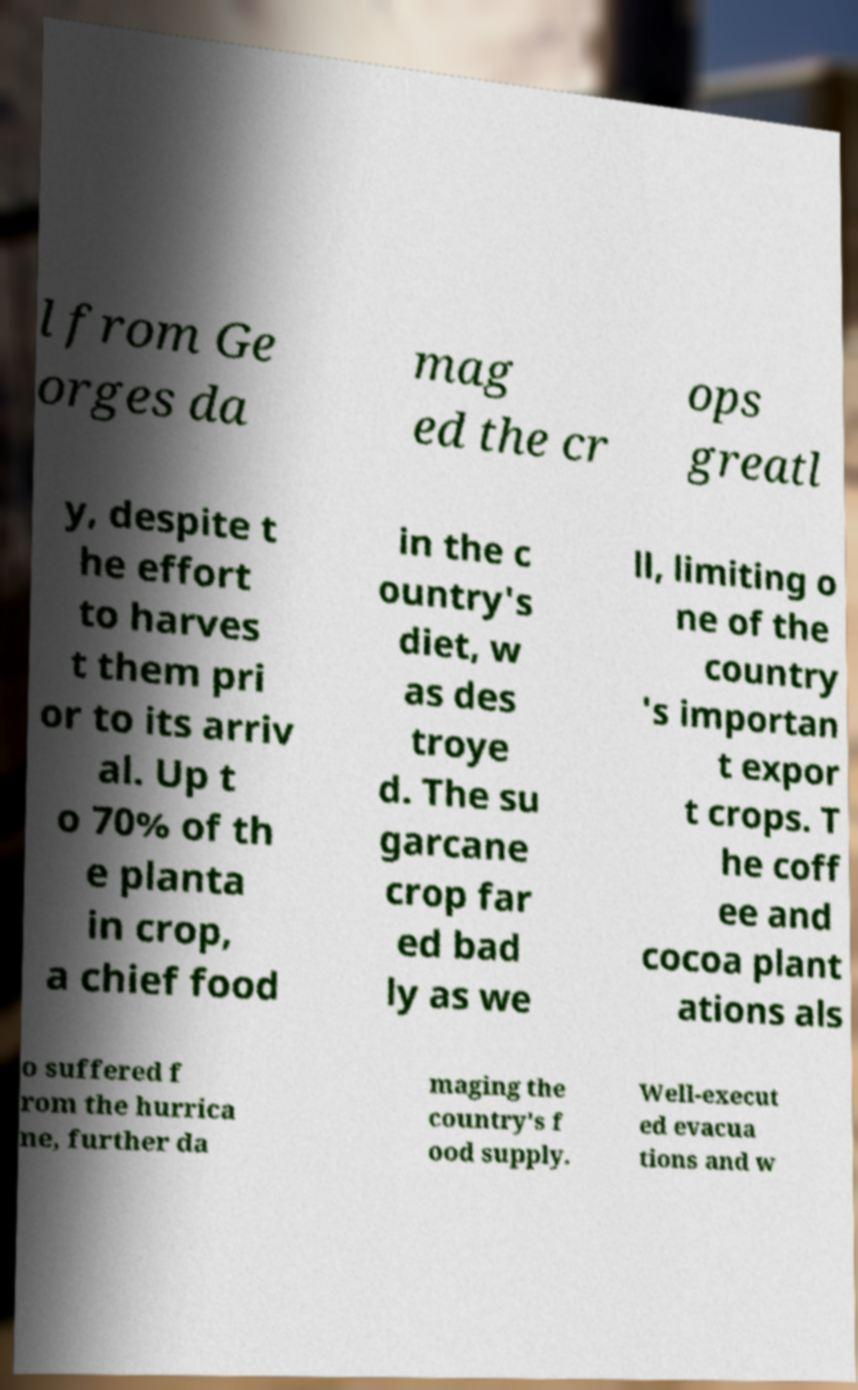Could you assist in decoding the text presented in this image and type it out clearly? l from Ge orges da mag ed the cr ops greatl y, despite t he effort to harves t them pri or to its arriv al. Up t o 70% of th e planta in crop, a chief food in the c ountry's diet, w as des troye d. The su garcane crop far ed bad ly as we ll, limiting o ne of the country 's importan t expor t crops. T he coff ee and cocoa plant ations als o suffered f rom the hurrica ne, further da maging the country's f ood supply. Well-execut ed evacua tions and w 